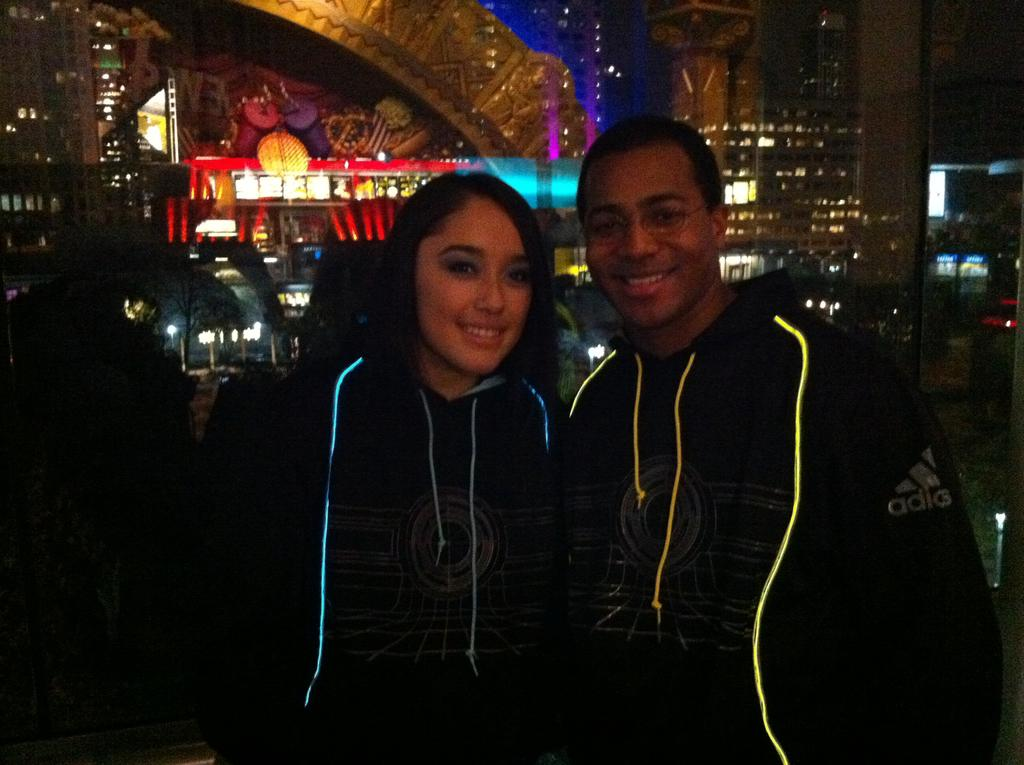Where was the image taken? The image was taken indoors. How many people are in the foreground of the image? There are two persons in the foreground of the image. What is the facial expression of the persons in the image? The persons are smiling. What type of clothing are the persons wearing? The persons are wearing hoodies. What are the persons doing in the image? The persons are standing. What can be seen in the background of the image? There are lights and other objects visible in the background of the image. What type of duck is visible in the image? There is no duck present in the image. What company is represented by the persons in the image? The image does not show any company affiliation or representation. 